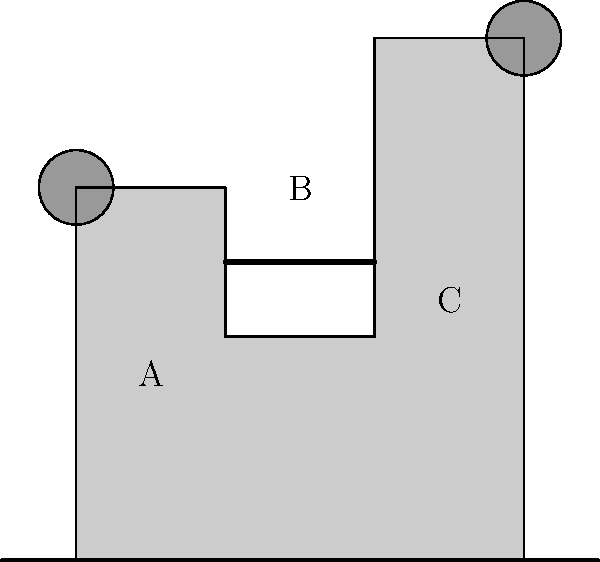In the complex castle structure shown above, which resembles the intricate designs often seen in Castlevania games, determine the genus of the structure. Assume that the castle is a solid object and any internal spaces are filled. How many "holes" does this structure have from a topological perspective? To determine the genus of this castle structure, we need to analyze it from a topological perspective. Let's break it down step-by-step:

1. First, recall that in topology, the genus of a surface is the number of "holes" or "handles" it has. For a solid object, we're looking for through-holes.

2. Looking at the castle structure:
   a) The main body of the castle doesn't have any through-holes.
   b) The two towers (circular structures) don't create through-holes.
   c) The different levels and sections (A, B, C) don't create topological holes as they're assumed to be solid.

3. The key feature to notice is the bridge connecting two parts of the castle (between sections A and C).

4. This bridge creates a single through-hole in the structure. Imagine a loop passing through this hole - it can't be contracted to a point without leaving the structure.

5. In topological terms, this castle is homeomorphic to a torus (donut shape) with some additional features that don't affect its genus.

Therefore, from a topological perspective, this castle structure has one "hole", giving it a genus of 1.
Answer: 1 